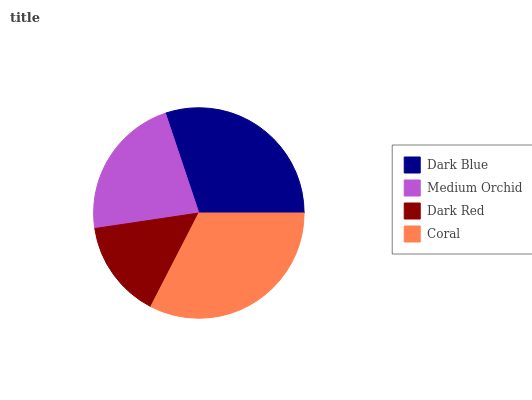Is Dark Red the minimum?
Answer yes or no. Yes. Is Coral the maximum?
Answer yes or no. Yes. Is Medium Orchid the minimum?
Answer yes or no. No. Is Medium Orchid the maximum?
Answer yes or no. No. Is Dark Blue greater than Medium Orchid?
Answer yes or no. Yes. Is Medium Orchid less than Dark Blue?
Answer yes or no. Yes. Is Medium Orchid greater than Dark Blue?
Answer yes or no. No. Is Dark Blue less than Medium Orchid?
Answer yes or no. No. Is Dark Blue the high median?
Answer yes or no. Yes. Is Medium Orchid the low median?
Answer yes or no. Yes. Is Dark Red the high median?
Answer yes or no. No. Is Dark Blue the low median?
Answer yes or no. No. 